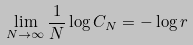<formula> <loc_0><loc_0><loc_500><loc_500>\lim _ { N \rightarrow \infty } \frac { 1 } { N } \log C _ { N } = - \log r</formula> 